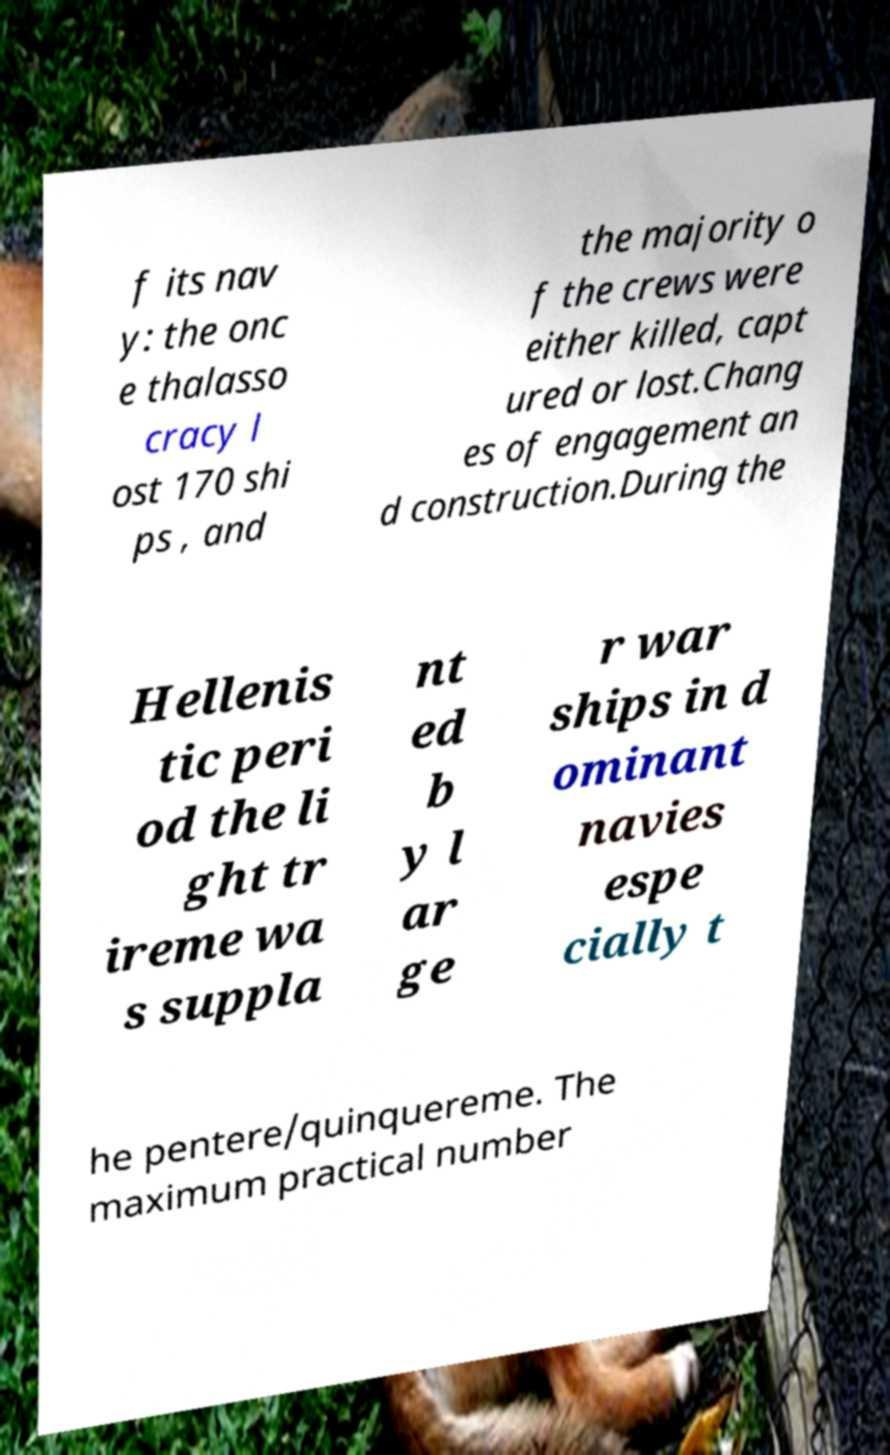Can you accurately transcribe the text from the provided image for me? f its nav y: the onc e thalasso cracy l ost 170 shi ps , and the majority o f the crews were either killed, capt ured or lost.Chang es of engagement an d construction.During the Hellenis tic peri od the li ght tr ireme wa s suppla nt ed b y l ar ge r war ships in d ominant navies espe cially t he pentere/quinquereme. The maximum practical number 